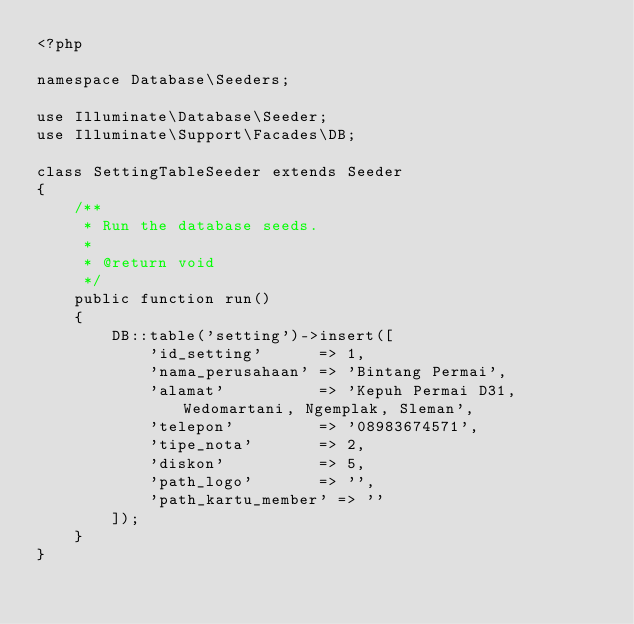Convert code to text. <code><loc_0><loc_0><loc_500><loc_500><_PHP_><?php

namespace Database\Seeders;

use Illuminate\Database\Seeder;
use Illuminate\Support\Facades\DB;

class SettingTableSeeder extends Seeder
{
    /**
     * Run the database seeds.
     *
     * @return void
     */
    public function run()
    {
        DB::table('setting')->insert([
            'id_setting'      => 1,
            'nama_perusahaan' => 'Bintang Permai',
            'alamat'          => 'Kepuh Permai D31, Wedomartani, Ngemplak, Sleman',
            'telepon'         => '08983674571',
            'tipe_nota'       => 2,
            'diskon'          => 5,
            'path_logo'       => '',
            'path_kartu_member' => ''
        ]);
    }
}
</code> 